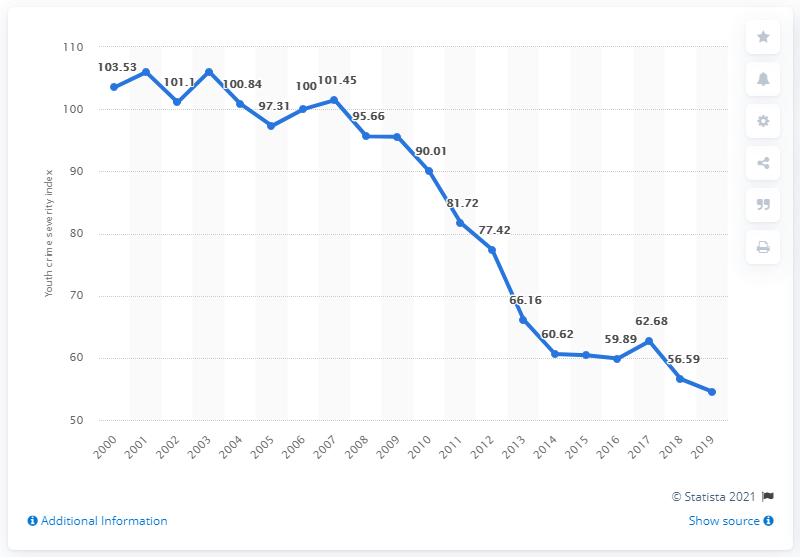Give some essential details in this illustration. The year with the lowest youth crime index was 2019. In Canada in 2019, the Youth Crime Severity Index was 54.55, representing a decline from the previous year. The Youth Crime Severity Index in 2000 was 103.53. Overall, the trend for youth crime severity index is declining, indicating a decrease in the level of youth crime over time. 